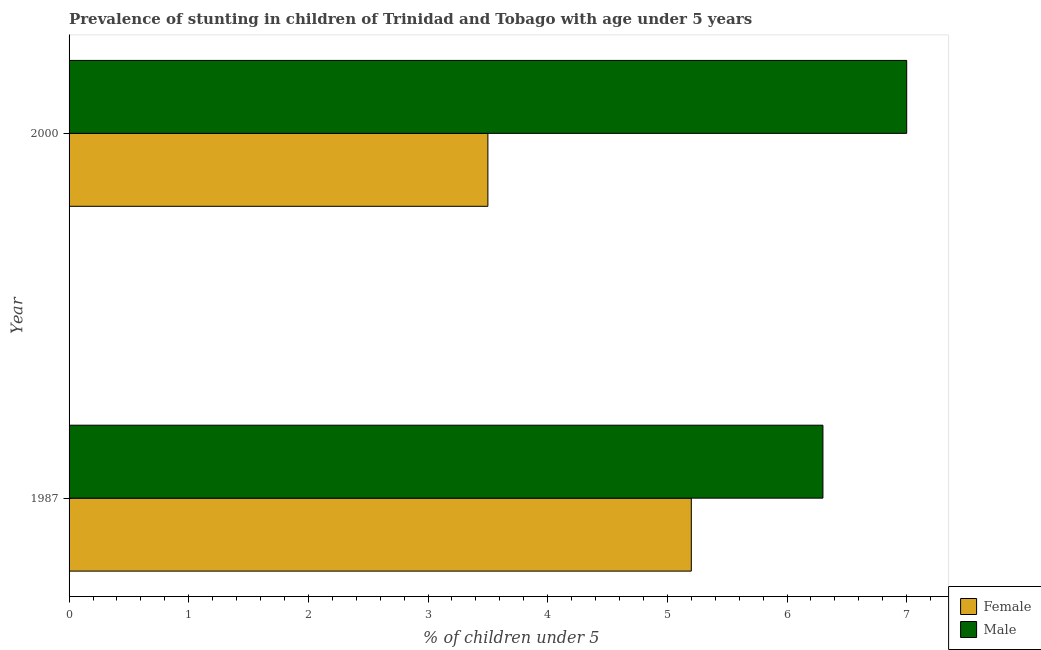How many different coloured bars are there?
Your answer should be very brief. 2. Are the number of bars per tick equal to the number of legend labels?
Ensure brevity in your answer.  Yes. Are the number of bars on each tick of the Y-axis equal?
Your answer should be compact. Yes. How many bars are there on the 2nd tick from the top?
Keep it short and to the point. 2. What is the label of the 1st group of bars from the top?
Provide a short and direct response. 2000. Across all years, what is the maximum percentage of stunted male children?
Your answer should be compact. 7. Across all years, what is the minimum percentage of stunted female children?
Make the answer very short. 3.5. In which year was the percentage of stunted male children minimum?
Provide a succinct answer. 1987. What is the total percentage of stunted female children in the graph?
Provide a succinct answer. 8.7. What is the difference between the percentage of stunted female children in 2000 and the percentage of stunted male children in 1987?
Provide a succinct answer. -2.8. What is the average percentage of stunted female children per year?
Your response must be concise. 4.35. What is the ratio of the percentage of stunted male children in 1987 to that in 2000?
Make the answer very short. 0.9. Are the values on the major ticks of X-axis written in scientific E-notation?
Make the answer very short. No. Does the graph contain any zero values?
Your answer should be compact. No. Where does the legend appear in the graph?
Your response must be concise. Bottom right. What is the title of the graph?
Ensure brevity in your answer.  Prevalence of stunting in children of Trinidad and Tobago with age under 5 years. What is the label or title of the X-axis?
Your answer should be very brief.  % of children under 5. What is the label or title of the Y-axis?
Ensure brevity in your answer.  Year. What is the  % of children under 5 in Female in 1987?
Your response must be concise. 5.2. What is the  % of children under 5 in Male in 1987?
Provide a succinct answer. 6.3. What is the  % of children under 5 in Female in 2000?
Keep it short and to the point. 3.5. Across all years, what is the maximum  % of children under 5 in Female?
Offer a terse response. 5.2. Across all years, what is the minimum  % of children under 5 of Male?
Make the answer very short. 6.3. What is the difference between the  % of children under 5 of Female in 1987 and that in 2000?
Provide a short and direct response. 1.7. What is the difference between the  % of children under 5 of Male in 1987 and that in 2000?
Offer a very short reply. -0.7. What is the difference between the  % of children under 5 of Female in 1987 and the  % of children under 5 of Male in 2000?
Provide a succinct answer. -1.8. What is the average  % of children under 5 in Female per year?
Your response must be concise. 4.35. What is the average  % of children under 5 of Male per year?
Your answer should be very brief. 6.65. In the year 1987, what is the difference between the  % of children under 5 in Female and  % of children under 5 in Male?
Ensure brevity in your answer.  -1.1. In the year 2000, what is the difference between the  % of children under 5 of Female and  % of children under 5 of Male?
Your answer should be compact. -3.5. What is the ratio of the  % of children under 5 in Female in 1987 to that in 2000?
Give a very brief answer. 1.49. What is the ratio of the  % of children under 5 in Male in 1987 to that in 2000?
Keep it short and to the point. 0.9. What is the difference between the highest and the second highest  % of children under 5 in Male?
Your answer should be compact. 0.7. What is the difference between the highest and the lowest  % of children under 5 in Male?
Make the answer very short. 0.7. 